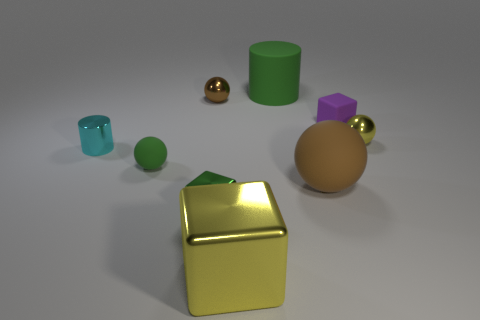What is the material of the big thing that is the same color as the small shiny cube?
Ensure brevity in your answer.  Rubber. Does the tiny purple cube have the same material as the brown sphere behind the small shiny cylinder?
Offer a very short reply. No. What color is the tiny rubber thing that is in front of the cylinder left of the brown object behind the small green matte ball?
Provide a short and direct response. Green. Does the large cube have the same color as the tiny shiny thing that is on the right side of the brown matte sphere?
Keep it short and to the point. Yes. The matte cylinder is what color?
Offer a very short reply. Green. The object in front of the tiny block left of the yellow shiny thing that is left of the big cylinder is what shape?
Give a very brief answer. Cube. What number of other things are the same color as the small rubber cube?
Provide a succinct answer. 0. Are there more small yellow metallic objects that are behind the yellow metallic ball than brown metallic objects that are in front of the tiny brown ball?
Your response must be concise. No. Are there any big rubber objects in front of the tiny purple matte object?
Offer a terse response. Yes. The big object that is both in front of the green rubber sphere and behind the large metal thing is made of what material?
Your response must be concise. Rubber. 